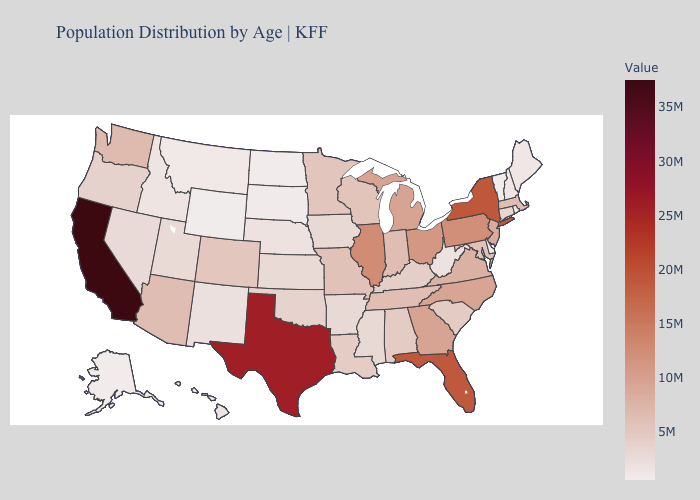Which states have the lowest value in the MidWest?
Short answer required. North Dakota. Does Washington have a higher value than Texas?
Keep it brief. No. Does Michigan have the lowest value in the USA?
Keep it brief. No. Does Minnesota have the highest value in the MidWest?
Short answer required. No. 